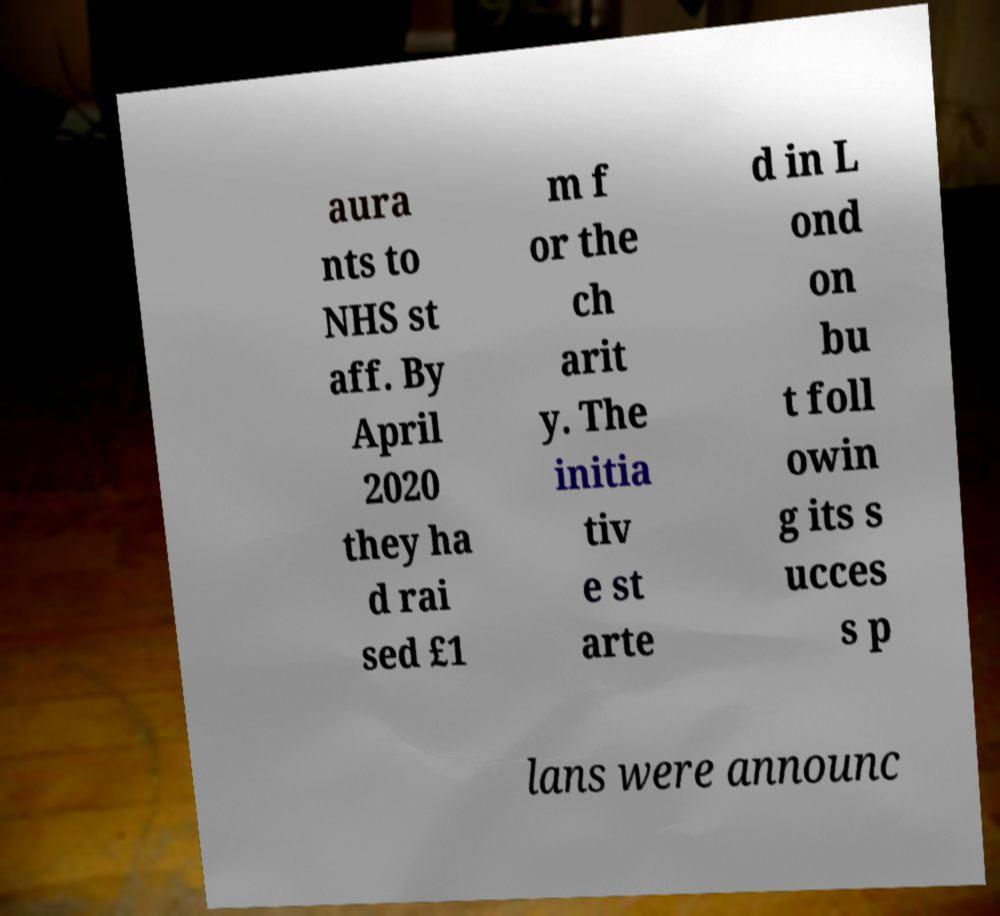Can you read and provide the text displayed in the image?This photo seems to have some interesting text. Can you extract and type it out for me? aura nts to NHS st aff. By April 2020 they ha d rai sed £1 m f or the ch arit y. The initia tiv e st arte d in L ond on bu t foll owin g its s ucces s p lans were announc 